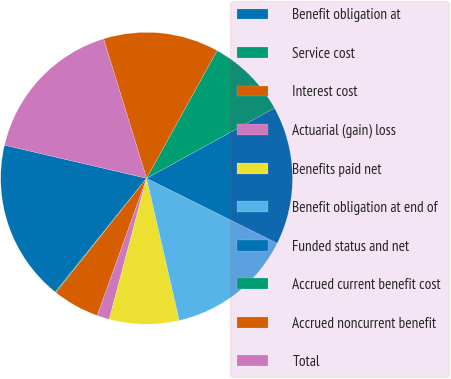Convert chart. <chart><loc_0><loc_0><loc_500><loc_500><pie_chart><fcel>Benefit obligation at<fcel>Service cost<fcel>Interest cost<fcel>Actuarial (gain) loss<fcel>Benefits paid net<fcel>Benefit obligation at end of<fcel>Funded status and net<fcel>Accrued current benefit cost<fcel>Accrued noncurrent benefit<fcel>Total<nl><fcel>17.87%<fcel>0.1%<fcel>5.18%<fcel>1.37%<fcel>7.72%<fcel>14.06%<fcel>15.33%<fcel>8.98%<fcel>12.79%<fcel>16.6%<nl></chart> 